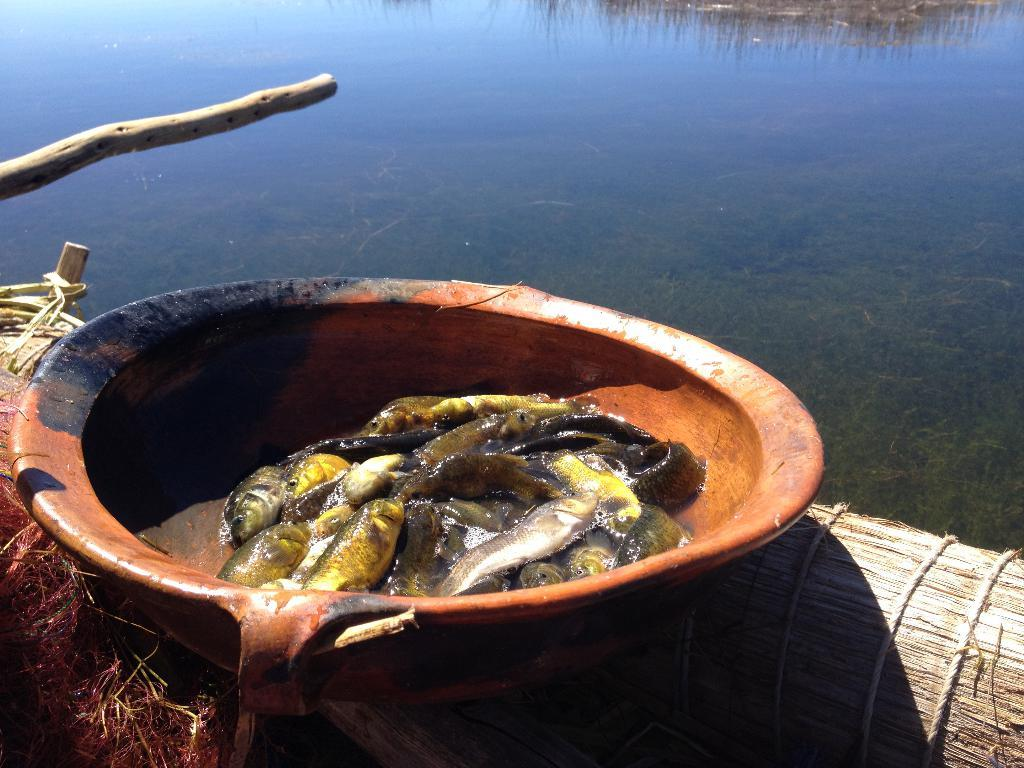What is located in the center of the image? There is a bowl in the middle of the image. What is inside the bowl? There are fishes in the bowl. What can be seen behind the bowl? There is water visible behind the bowl. What type of account does the fish have in the image? There is no indication of an account in the image; it features a bowl with fishes in it. What fictional character is depicted in the image? There is no fictional character present in the image; it features a bowl with fishes in it. 